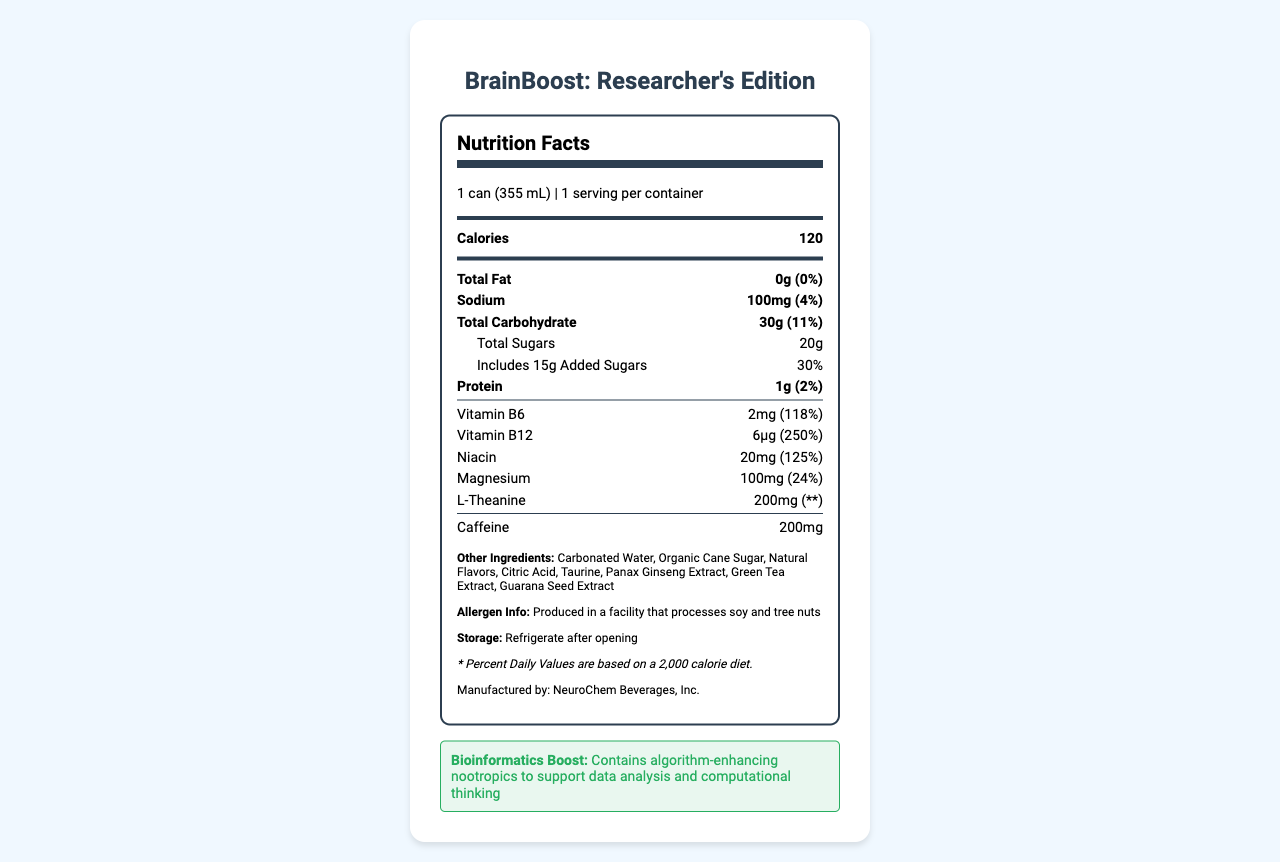what is the serving size? The serving size is clearly indicated at the top of the label: "serving size: 1 can (355 mL)".
Answer: 1 can (355 mL) how many calories are there per serving? Under the "Nutrition Facts" heading, the calorie count is listed as 120.
Answer: 120 what is the total fat content and its daily value percentage? The total fat content is specified as "0g" with a daily value percentage of "0%".
Answer: 0g, 0% how much caffeine does this energy drink contain? The caffeine content is listed at the bottom of the vitamin and minerals section as "Caffeine: 200mg".
Answer: 200mg what vitamins and minerals are included in the drink and their daily value percentages? The vitamins and minerals and their daily values are listed under the vitamins and minerals section.
Answer: Vitamin B6 (118%), Vitamin B12 (250%), Niacin (125%), Magnesium (24%), L-Theanine (N/A) what are the additional ingredients in this energy drink? The additional ingredients are listed at the bottom of the label in the "Other Ingredients" section.
Answer: Carbonated Water, Organic Cane Sugar, Natural Flavors, Citric Acid, Taurine, Panax Ginseng Extract, Green Tea Extract, Guarana Seed Extract how much added sugars does the energy drink contain? A. 10g B. 15g C. 20g D. 5g The label states "Includes 15g Added Sugars" under the total sugars section.
Answer: B. 15g which company manufactures this energy drink? A. BrainFuel Labs B. NeuroChem Beverages, Inc. C. Energy Boost Ltd. The manufacturer is listed at the bottom of the label as "Manufactured by: NeuroChem Beverages, Inc."
Answer: B. NeuroChem Beverages, Inc. is this product suitable for people with tree nut allergies? The allergen info section mentions that the product is produced in a facility that processes tree nuts.
Answer: No should the drink be refrigerated after opening? The storage section advises to "Refrigerate after opening."
Answer: Yes summarize the entire document. The summary describes all the essential parts of the document, emphasizing its relevance for researchers and the detailed nutritional content.
Answer: The document is a comprehensive nutrition facts label for "BrainBoost: Researcher's Edition", an energy drink designed for researchers engaged in long computational sessions. It details the serving size, calories, macronutrients, caffeine content, and the included vitamins and minerals along with their daily values. Additional ingredients, allergen information, storage instructions, and the manufacturer's details are also provided. Moreover, it highlights the presence of nootropics aimed at enhancing bioinformatics and computational thinking. how much protein is present in this energy drink? I. 0g II. 0.5g III. 1g IV. 1.5g The protein amount is listed under the main nutrients section as "Protein: 1g".
Answer: III. 1g what is the daily value percentage for sodium? The daily value for sodium is indicated as "4%" next to the amount of sodium.
Answer: 4% which vitamin has the highest daily value percentage in this drink? Among the listed vitamins, Vitamin B12 has the highest daily value percentage at 250%.
Answer: Vitamin B12 can we determine how long the shelf life of this drink is from the provided information? The label does not contain any information about the shelf life of the product.
Answer: Cannot be determined 